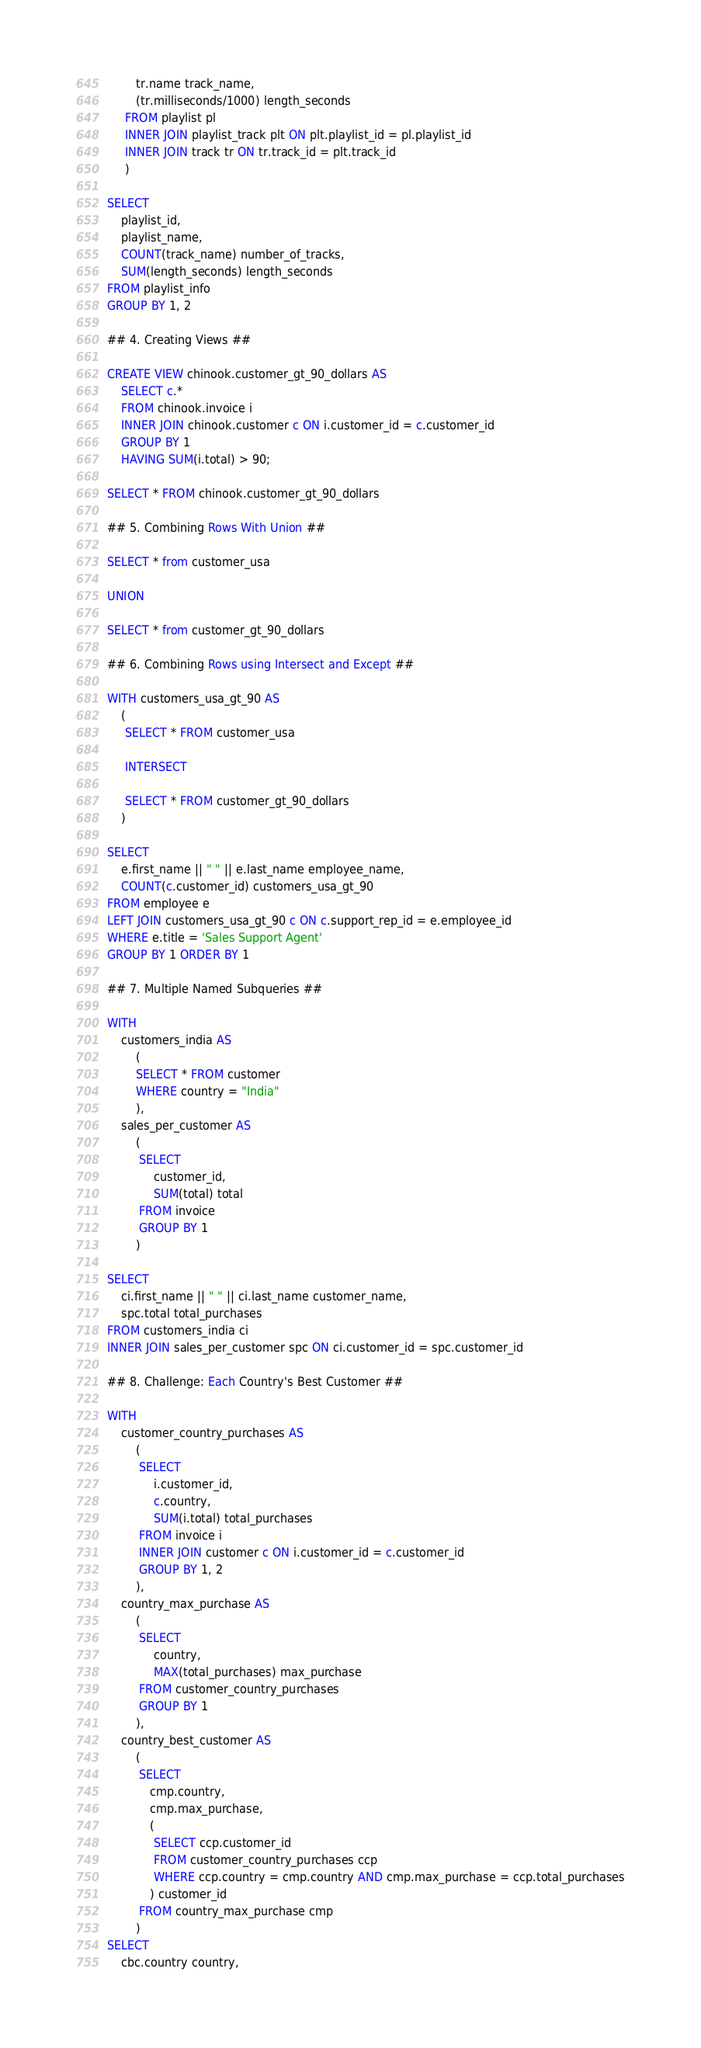Convert code to text. <code><loc_0><loc_0><loc_500><loc_500><_SQL_>        tr.name track_name,
        (tr.milliseconds/1000) length_seconds
     FROM playlist pl
     INNER JOIN playlist_track plt ON plt.playlist_id = pl.playlist_id
     INNER JOIN track tr ON tr.track_id = plt.track_id
     )
     
SELECT
    playlist_id,
    playlist_name,
    COUNT(track_name) number_of_tracks,
    SUM(length_seconds) length_seconds
FROM playlist_info
GROUP BY 1, 2

## 4. Creating Views ##

CREATE VIEW chinook.customer_gt_90_dollars AS 
    SELECT c.*
    FROM chinook.invoice i
    INNER JOIN chinook.customer c ON i.customer_id = c.customer_id
    GROUP BY 1
    HAVING SUM(i.total) > 90;
     
SELECT * FROM chinook.customer_gt_90_dollars

## 5. Combining Rows With Union ##

SELECT * from customer_usa

UNION

SELECT * from customer_gt_90_dollars

## 6. Combining Rows using Intersect and Except ##

WITH customers_usa_gt_90 AS
    (
     SELECT * FROM customer_usa

     INTERSECT

     SELECT * FROM customer_gt_90_dollars
    )

SELECT
    e.first_name || " " || e.last_name employee_name,
    COUNT(c.customer_id) customers_usa_gt_90
FROM employee e
LEFT JOIN customers_usa_gt_90 c ON c.support_rep_id = e.employee_id
WHERE e.title = 'Sales Support Agent'
GROUP BY 1 ORDER BY 1

## 7. Multiple Named Subqueries ##

WITH
    customers_india AS
        (
        SELECT * FROM customer
        WHERE country = "India"
        ),
    sales_per_customer AS
        (
         SELECT
             customer_id,
             SUM(total) total
         FROM invoice
         GROUP BY 1
        )

SELECT
    ci.first_name || " " || ci.last_name customer_name,
    spc.total total_purchases
FROM customers_india ci
INNER JOIN sales_per_customer spc ON ci.customer_id = spc.customer_id

## 8. Challenge: Each Country's Best Customer ##

WITH
    customer_country_purchases AS
        (
         SELECT
             i.customer_id,
             c.country,
             SUM(i.total) total_purchases
         FROM invoice i
         INNER JOIN customer c ON i.customer_id = c.customer_id
         GROUP BY 1, 2
        ),
    country_max_purchase AS
        (
         SELECT
             country,
             MAX(total_purchases) max_purchase
         FROM customer_country_purchases
         GROUP BY 1
        ),
    country_best_customer AS
        (
         SELECT
            cmp.country,
            cmp.max_purchase,
            (
             SELECT ccp.customer_id
             FROM customer_country_purchases ccp
             WHERE ccp.country = cmp.country AND cmp.max_purchase = ccp.total_purchases
            ) customer_id
         FROM country_max_purchase cmp
        )
SELECT
    cbc.country country,</code> 